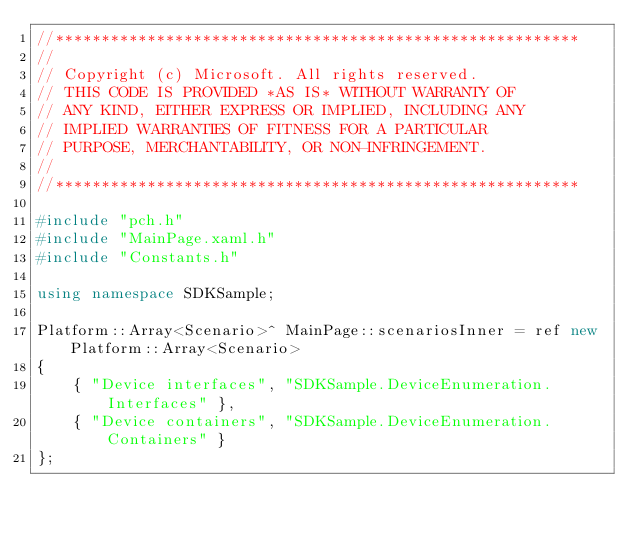Convert code to text. <code><loc_0><loc_0><loc_500><loc_500><_C++_>//*********************************************************
//
// Copyright (c) Microsoft. All rights reserved.
// THIS CODE IS PROVIDED *AS IS* WITHOUT WARRANTY OF
// ANY KIND, EITHER EXPRESS OR IMPLIED, INCLUDING ANY
// IMPLIED WARRANTIES OF FITNESS FOR A PARTICULAR
// PURPOSE, MERCHANTABILITY, OR NON-INFRINGEMENT.
//
//*********************************************************

#include "pch.h"
#include "MainPage.xaml.h"
#include "Constants.h"

using namespace SDKSample;

Platform::Array<Scenario>^ MainPage::scenariosInner = ref new Platform::Array<Scenario>  
{
    { "Device interfaces", "SDKSample.DeviceEnumeration.Interfaces" }, 
    { "Device containers", "SDKSample.DeviceEnumeration.Containers" }    
}; 
</code> 